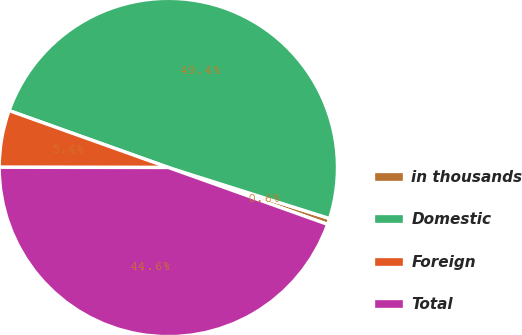<chart> <loc_0><loc_0><loc_500><loc_500><pie_chart><fcel>in thousands<fcel>Domestic<fcel>Foreign<fcel>Total<nl><fcel>0.58%<fcel>49.42%<fcel>5.44%<fcel>44.56%<nl></chart> 